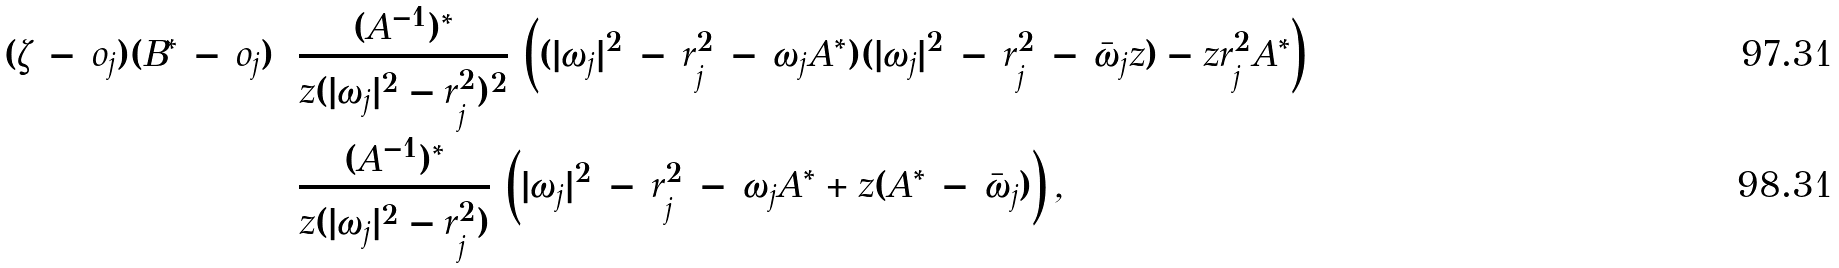Convert formula to latex. <formula><loc_0><loc_0><loc_500><loc_500>( \zeta \, - \, o _ { j } ) ( B ^ { * } \, - \, o _ { j } ) & = \frac { ( A ^ { - 1 } ) ^ { * } } { z ( | \omega _ { j } | ^ { 2 } - r _ { j } ^ { 2 } ) ^ { 2 } } \, \left ( ( | \omega _ { j } | ^ { 2 } \, - \, r _ { j } ^ { 2 } \, - \, \omega _ { j } A ^ { * } ) ( | \omega _ { j } | ^ { 2 } \, - \, r _ { j } ^ { 2 } \, - \, \bar { \omega } _ { j } z ) - z r _ { j } ^ { 2 } A ^ { * } \right ) \\ & = \frac { ( A ^ { - 1 } ) ^ { * } } { z ( | \omega _ { j } | ^ { 2 } - r _ { j } ^ { 2 } ) } \, \left ( | \omega _ { j } | ^ { 2 } \, - \, r _ { j } ^ { 2 } \, - \, \omega _ { j } A ^ { * } + z ( A ^ { * } \, - \, \bar { \omega } _ { j } ) \right ) ,</formula> 